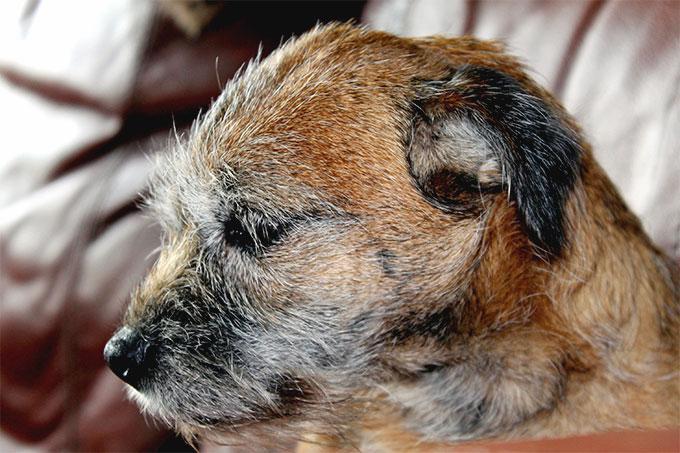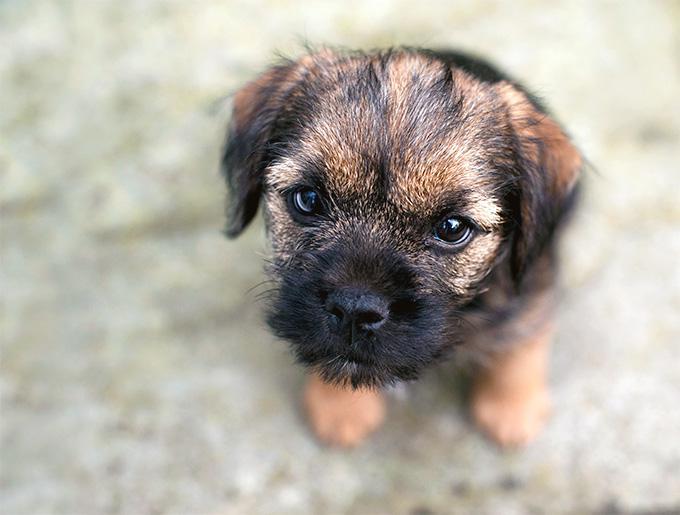The first image is the image on the left, the second image is the image on the right. Examine the images to the left and right. Is the description "A medallion can be seen hanging from the collar of the dog in the image on the left." accurate? Answer yes or no. No. 